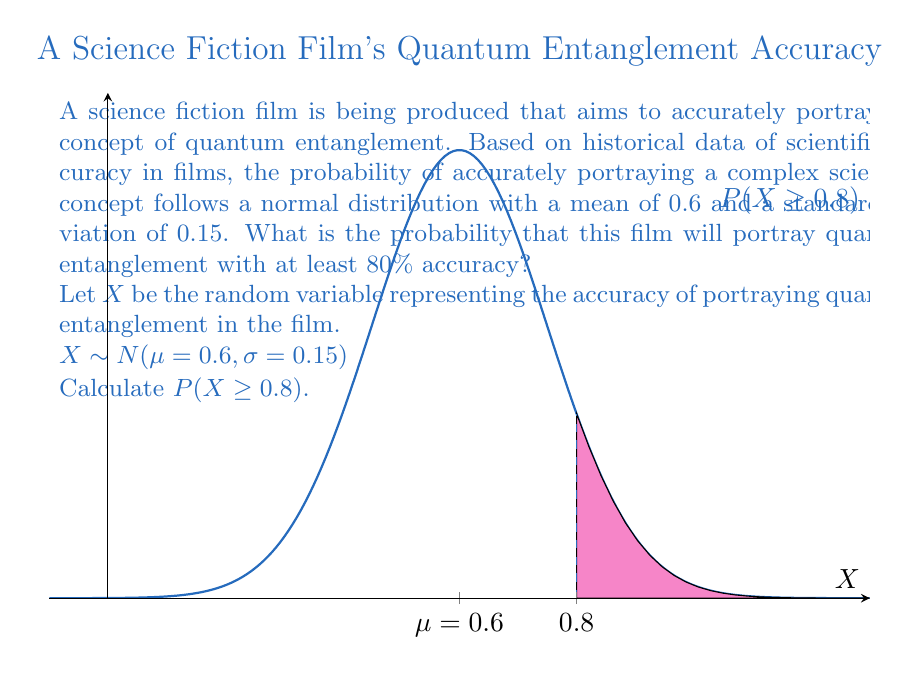Provide a solution to this math problem. To solve this problem, we need to follow these steps:

1) First, we need to standardize the random variable X to get a Z-score:

   $Z = \frac{X - \mu}{\sigma}$

2) We want to find P(X ≥ 0.8), which is equivalent to:

   $P(Z \geq \frac{0.8 - 0.6}{0.15})$

3) Calculate the Z-score:

   $Z = \frac{0.8 - 0.6}{0.15} = \frac{0.2}{0.15} \approx 1.33$

4) Now we need to find P(Z ≥ 1.33) using the standard normal distribution table or a calculator.

5) Using a standard normal distribution table or calculator, we find:

   P(Z ≥ 1.33) ≈ 0.0918

6) Therefore, the probability that the film will portray quantum entanglement with at least 80% accuracy is approximately 0.0918 or 9.18%.

This means there's about a 9.18% chance that the film will portray quantum entanglement with 80% accuracy or better, which is relatively low. This reflects the challenge of accurately portraying complex scientific concepts in films.
Answer: 0.0918 or 9.18% 